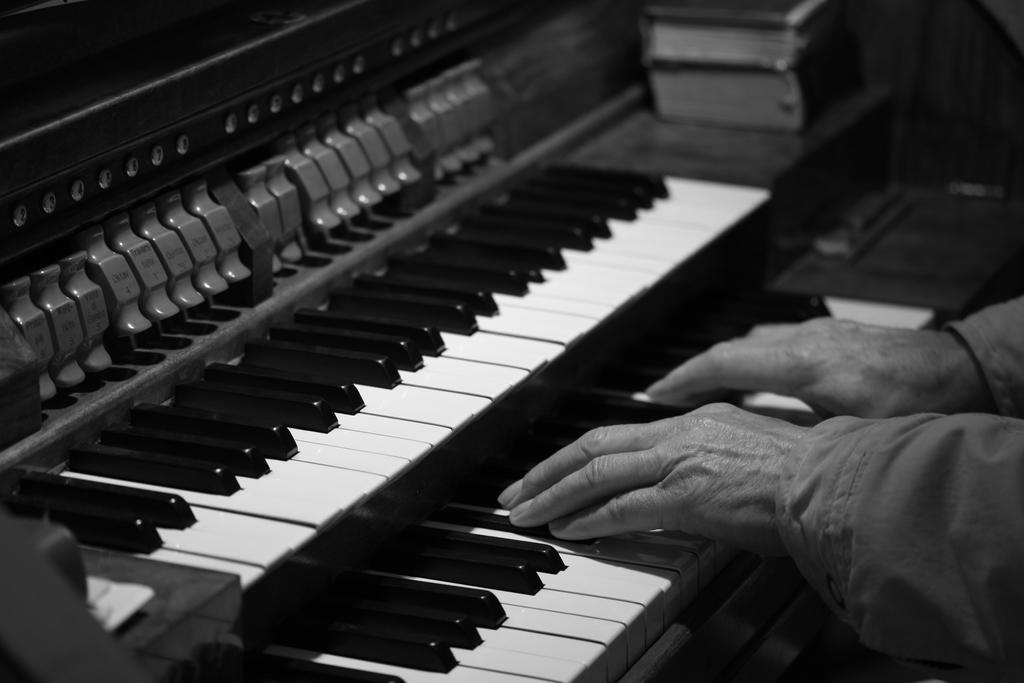What is the main object in the image? There is a piano in the image. Can you see any part of a person in the image? Yes, there are hands of a person visible in the image. What else can be seen in the image besides the piano and hands? There appear to be books in the top right corner of the image. Can you tell me how many monkeys are sitting on the piano in the image? There are no monkeys present in the image; it features a piano and a person's hands. What month is it in the image? The image does not provide any information about the month or time of year. 